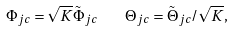Convert formula to latex. <formula><loc_0><loc_0><loc_500><loc_500>\Phi _ { j c } = \sqrt { K } \tilde { \Phi } _ { j c } \quad \Theta _ { j c } = \tilde { \Theta } _ { j c } / \sqrt { K } ,</formula> 